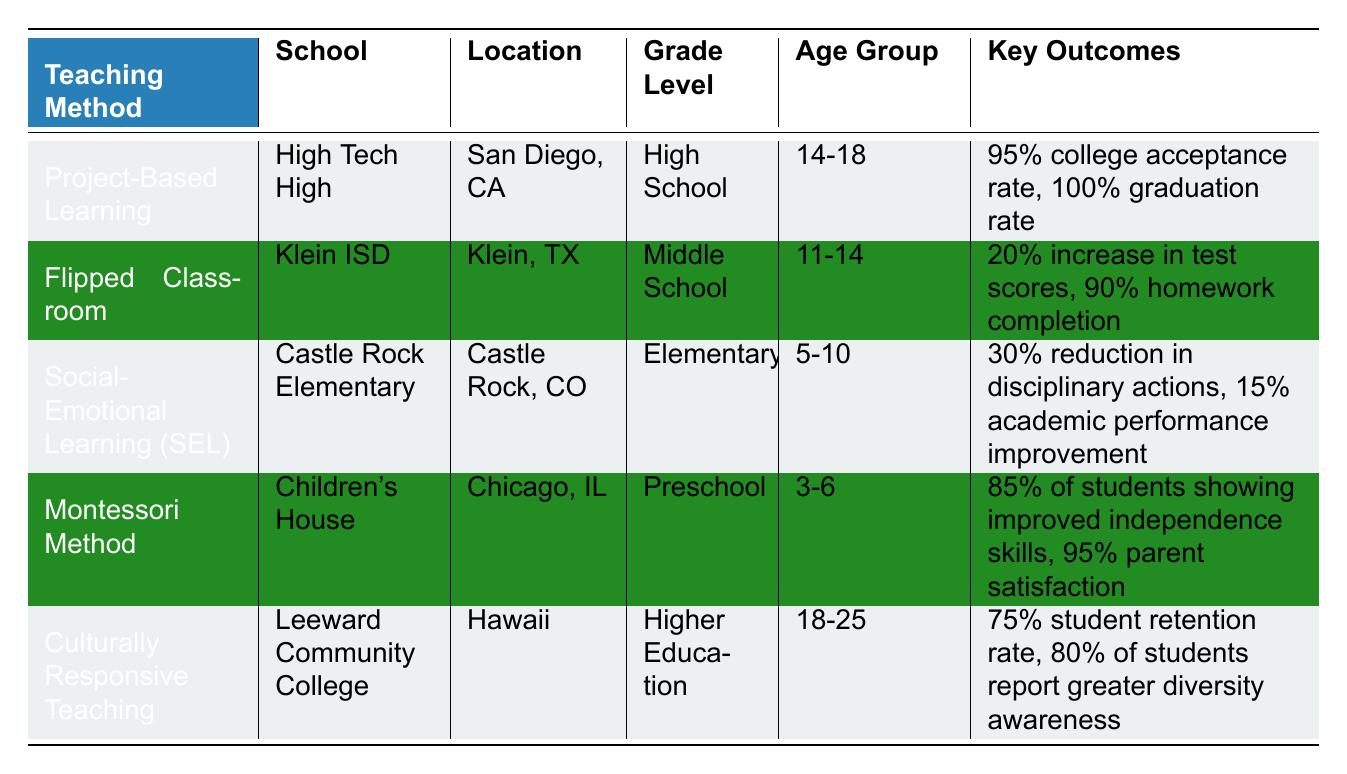What method has the highest college acceptance rate? The table shows that Project-Based Learning at High Tech High has a college acceptance rate of 95%, which is the highest among all the methods listed.
Answer: 95% Which school is associated with Social-Emotional Learning? The table indicates that Castle Rock Elementary is the school implementing Social-Emotional Learning.
Answer: Castle Rock Elementary What is the average student satisfaction rate across the methods listed? The table does not directly provide a student satisfaction rate for every method. However, we can find relevant satisfaction rates: 85% for Project-Based Learning, 90% for Social-Emotional Learning, 95% for Montessori Method, and 80% for Culturally Responsive Teaching. The average is calculated as (85 + 90 + 95 + 80) / 4 = 87.5%.
Answer: 87.5% Is it true that the Montessori Method has a higher parent satisfaction than the Culturally Responsive Teaching method? Yes, the Montessori Method indicates a parent satisfaction of 95%, while Culturally Responsive Teaching states that 80% of students report greater diversity awareness, which does not directly mention parent satisfaction. Thus, we cannot compare the two directly; however, since we are specifically looking for parent satisfaction, the statement is true based on information available.
Answer: Yes Which teaching method resulted in the most significant improvement in homework completion rates? The Flipped Classroom method at Klein ISD showed a 90% homework completion rate, the highest recorded in the table. While other methods deal with different aspects of learning, homework completion is only explicitly mentioned for the Flipped Classroom.
Answer: 90% 